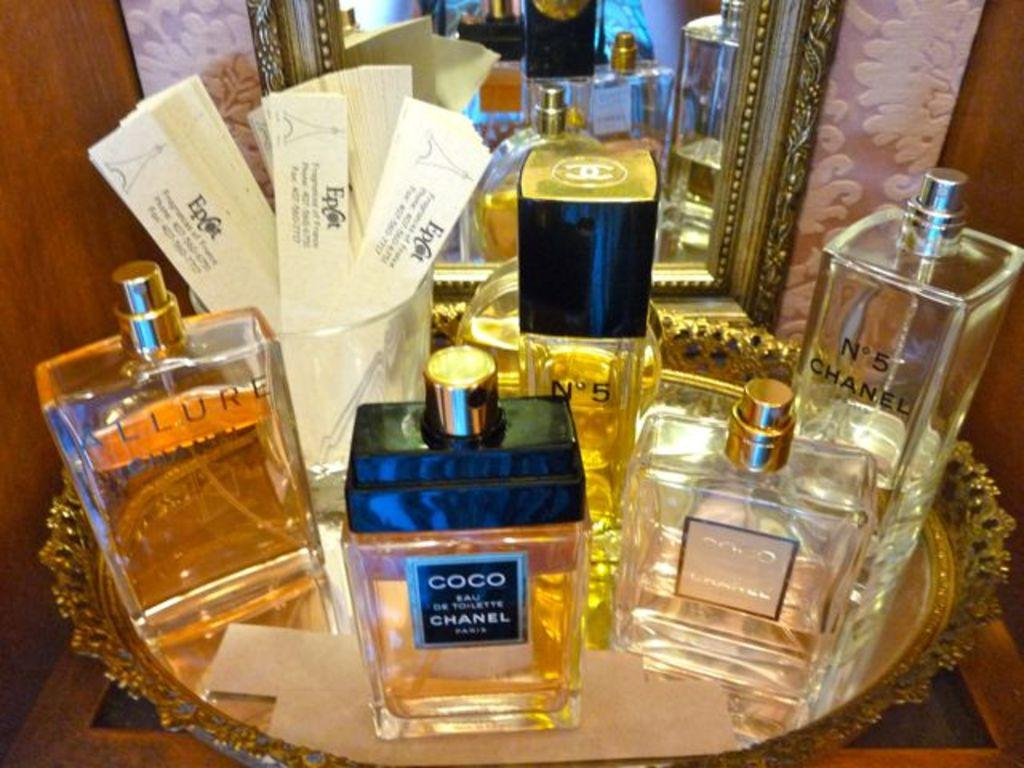<image>
Provide a brief description of the given image. Several bottles of differently branded perfumes from coco chanel. 